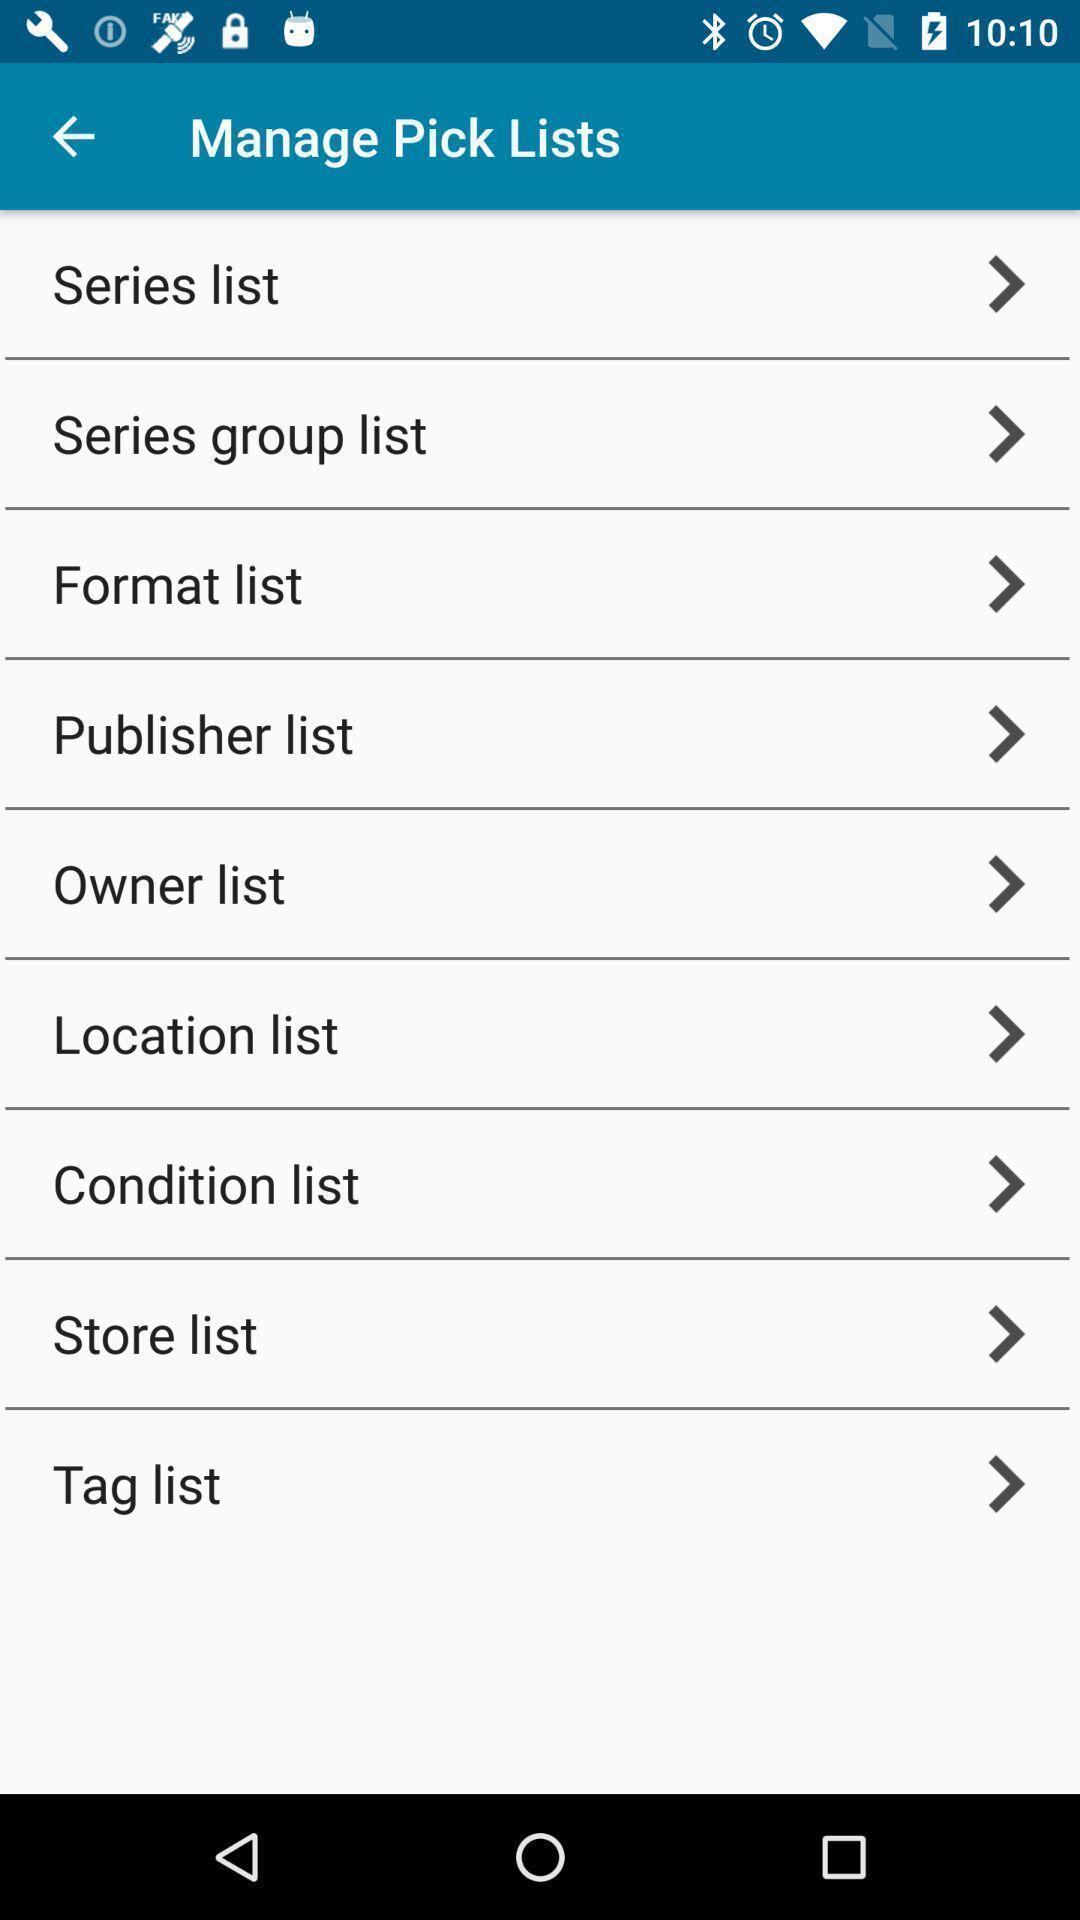Please provide a description for this image. Screen shows manage pick lists. 